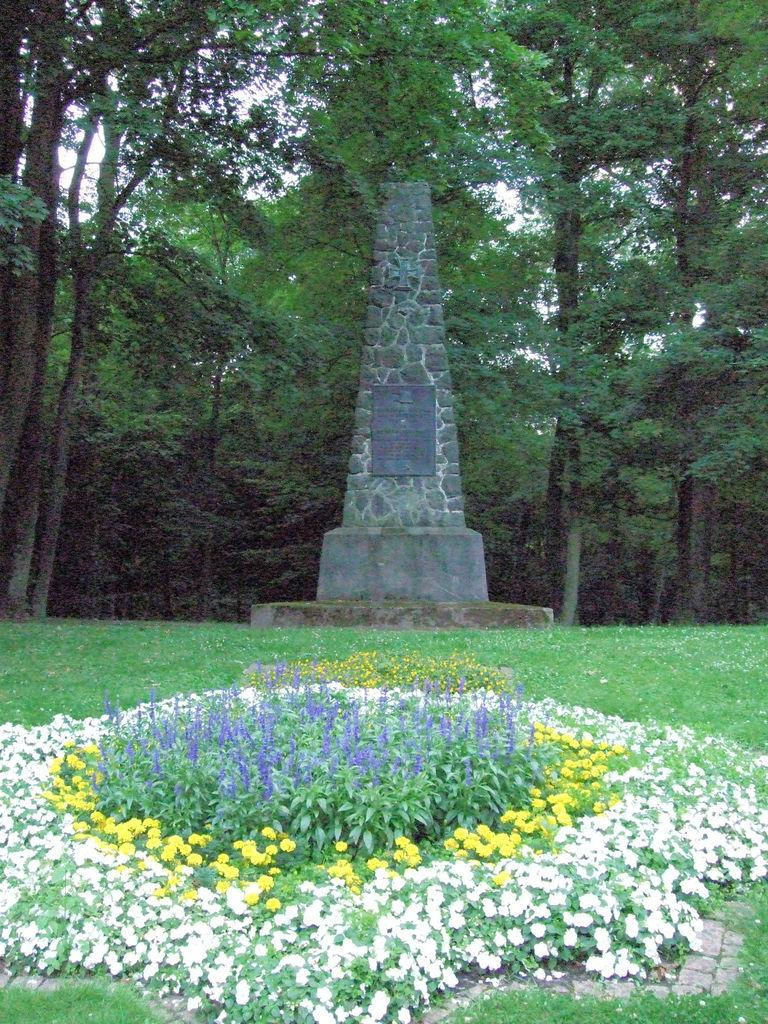What type of living organisms can be seen in the image? Plants can be seen in the image. What is located in the middle of the image? There is a foundation stone in the middle of the image. What can be seen in the background of the image? Trees are visible in the background of the image. What type of connection can be seen between the plants and the wilderness in the image? There is no wilderness present in the image, and the plants are not connected to any wilderness. 